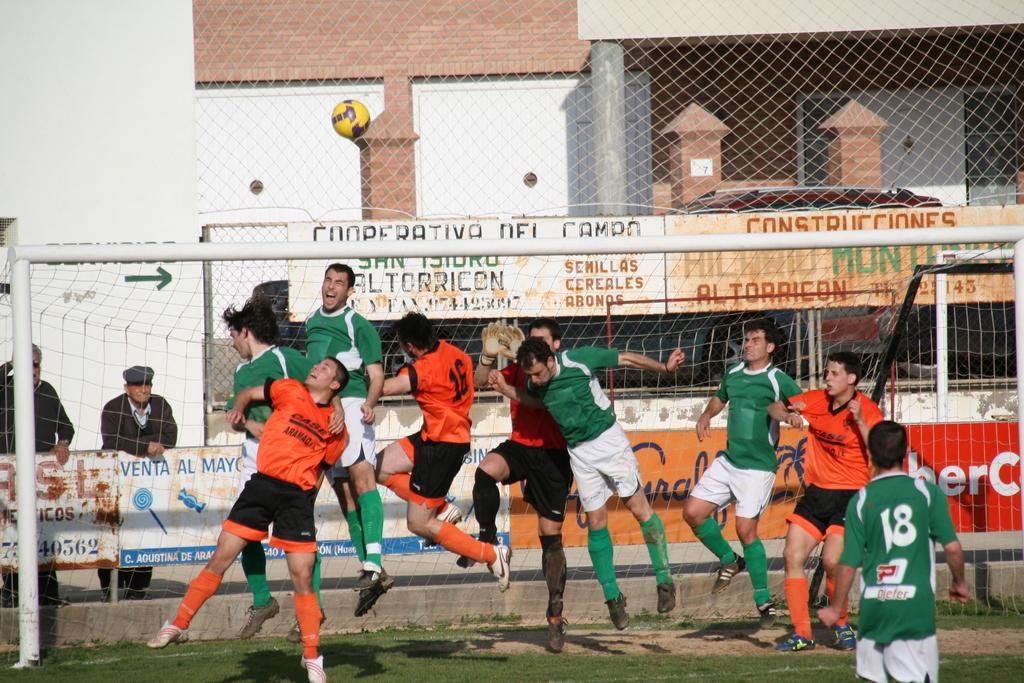Provide a one-sentence caption for the provided image. Green and orange shirted soccer players leap for the ball at the Cooperativa Del Campo soccer field. 